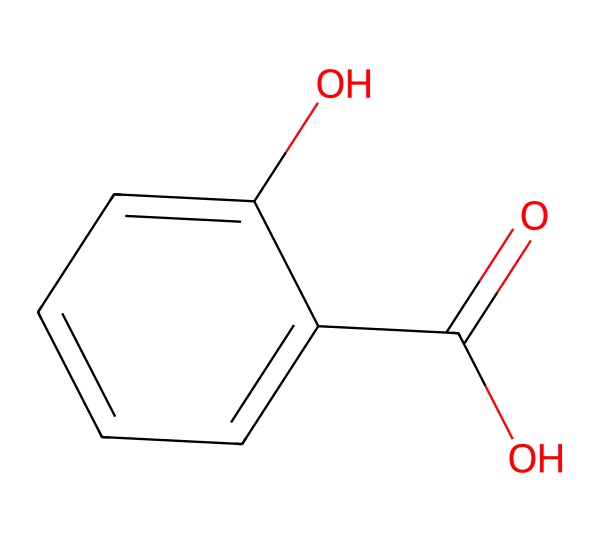What is the molecular formula of salicylic acid? To determine the molecular formula from the SMILES, count the number of each type of atom present in the structure. The structure includes 7 carbon (C) atoms, 6 hydrogen (H) atoms, and 3 oxygen (O) atoms. Therefore, the molecular formula is C7H6O3.
Answer: C7H6O3 How many hydroxyl groups are present in salicylic acid? A hydroxyl group (-OH) is identified in the structure. By examining the SMILES representation, there are two -OH groups in the structure: one attached to the aromatic ring and one part of the carboxylic acid group.
Answer: 2 Which functional groups are present in salicylic acid? The chemical structure shows two main functional groups: a hydroxyl group (-OH) and a carboxylic acid group (-COOH). The presence of these groups is identified by their typical structures located in the molecule.
Answer: hydroxyl and carboxylic acid What is the total number of rings in salicylic acid? The chemical structure shows a single benzene ring in the molecular composition, which can be identified by the arrangement of carbon atoms forming a cyclic structure.
Answer: 1 How does the presence of the hydroxyl group affect the solubility of salicylic acid? The hydroxyl group increases solubility in water due to its ability to form hydrogen bonds with water molecules. This is a common property of phenolic compounds, which enhances their interaction with polar solvents.
Answer: increases What type of compound is salicylic acid classified as? Salicylic acid is classified as a phenolic compound due to the presence of a hydroxyl group attached directly to an aromatic ring. This classification is based on the chemical structure and functional group characteristics.
Answer: phenolic compound 